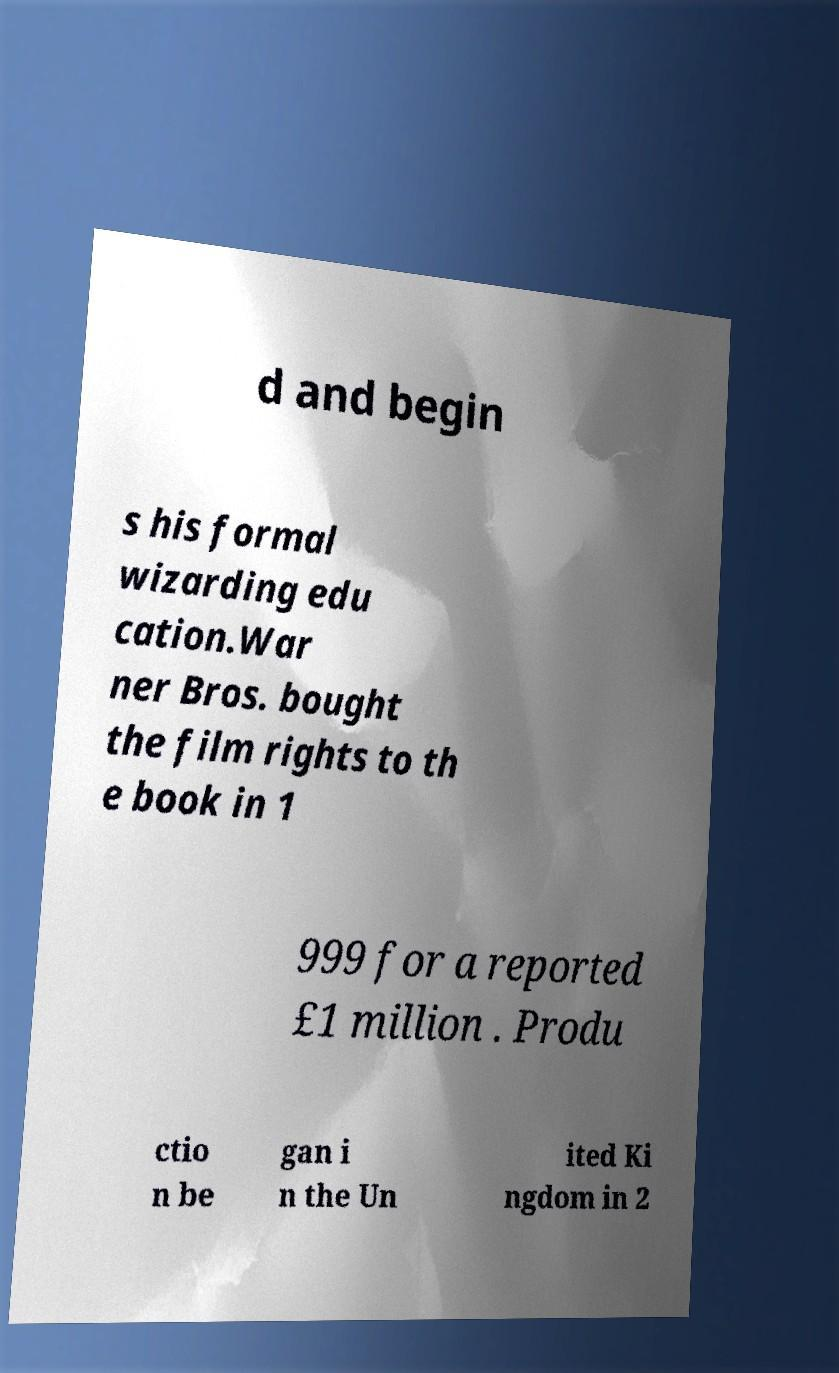For documentation purposes, I need the text within this image transcribed. Could you provide that? d and begin s his formal wizarding edu cation.War ner Bros. bought the film rights to th e book in 1 999 for a reported £1 million . Produ ctio n be gan i n the Un ited Ki ngdom in 2 